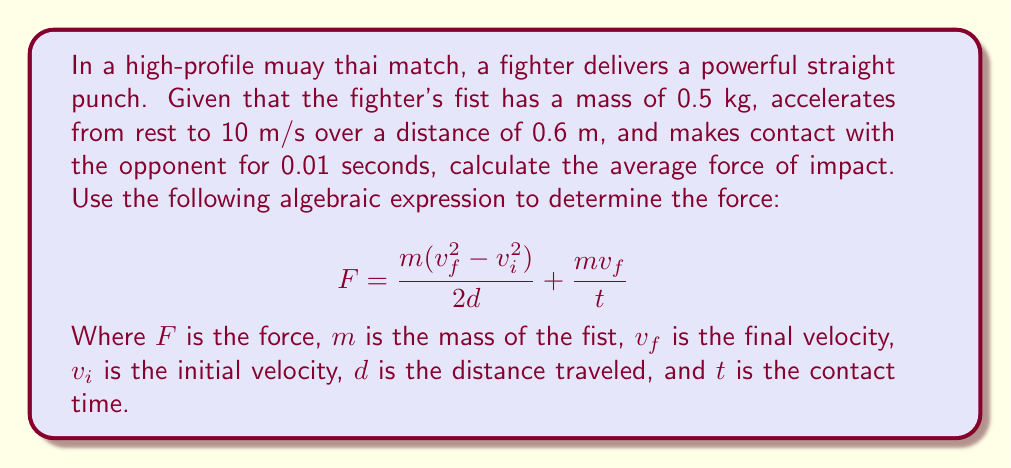Can you answer this question? Let's solve this problem step by step:

1) First, let's identify the given values:
   $m = 0.5$ kg
   $v_f = 10$ m/s
   $v_i = 0$ m/s (starting from rest)
   $d = 0.6$ m
   $t = 0.01$ s

2) Now, let's substitute these values into our formula:

   $$ F = \frac{0.5((10)^2 - 0^2)}{2(0.6)} + \frac{0.5(10)}{0.01} $$

3) Let's simplify the first term:
   $$ \frac{0.5(100)}{1.2} = \frac{50}{1.2} \approx 41.67 \text{ N} $$

4) Now the second term:
   $$ \frac{5}{0.01} = 500 \text{ N} $$

5) Adding these together:
   $$ F = 41.67 + 500 = 541.67 \text{ N} $$

6) Rounding to two decimal places:
   $$ F \approx 541.67 \text{ N} $$
Answer: $541.67 \text{ N}$ 